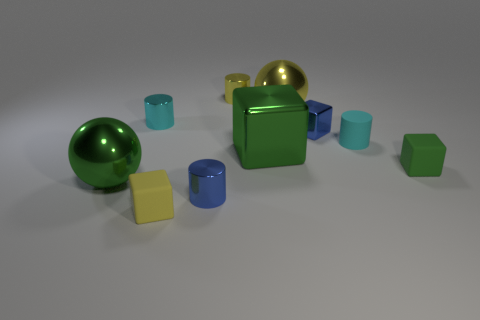Do the cyan cylinder that is right of the small metallic cube and the ball that is on the left side of the green shiny cube have the same size? From the perspective provided in the image, it is not entirely clear if the cyan cylinder and the ball are of the same size since they are not directly next to each other for an accurate comparison. However, based on their apparent sizes in relation to nearby objects, they seem to be of different sizes. The cyan cylinder on the right of the small metallic cube appears to be closer to the camera and consequently looks larger, whereas the ball to the left of the shiny green cube seems smaller in comparison. 